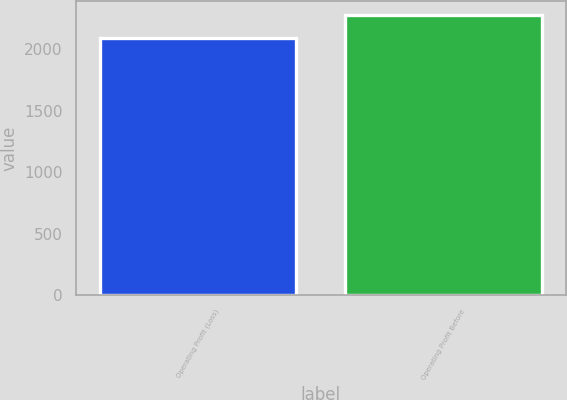Convert chart. <chart><loc_0><loc_0><loc_500><loc_500><bar_chart><fcel>Operating Profit (Loss)<fcel>Operating Profit Before<nl><fcel>2093<fcel>2277<nl></chart> 